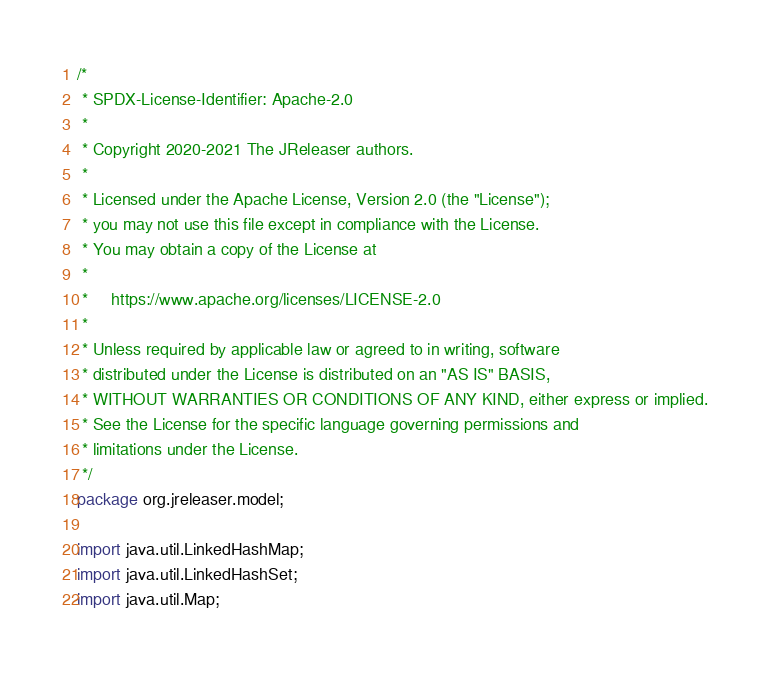Convert code to text. <code><loc_0><loc_0><loc_500><loc_500><_Java_>/*
 * SPDX-License-Identifier: Apache-2.0
 *
 * Copyright 2020-2021 The JReleaser authors.
 *
 * Licensed under the Apache License, Version 2.0 (the "License");
 * you may not use this file except in compliance with the License.
 * You may obtain a copy of the License at
 *
 *     https://www.apache.org/licenses/LICENSE-2.0
 *
 * Unless required by applicable law or agreed to in writing, software
 * distributed under the License is distributed on an "AS IS" BASIS,
 * WITHOUT WARRANTIES OR CONDITIONS OF ANY KIND, either express or implied.
 * See the License for the specific language governing permissions and
 * limitations under the License.
 */
package org.jreleaser.model;

import java.util.LinkedHashMap;
import java.util.LinkedHashSet;
import java.util.Map;</code> 